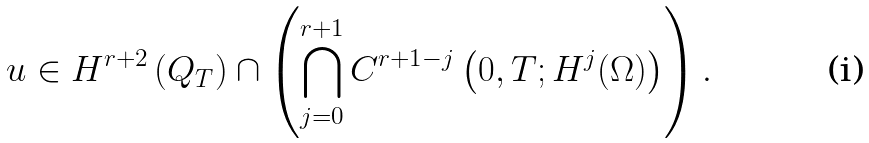<formula> <loc_0><loc_0><loc_500><loc_500>u \in H ^ { r + 2 } \left ( Q _ { T } \right ) \cap \left ( \bigcap _ { j = 0 } ^ { r + 1 } C ^ { r + 1 - j } \left ( 0 , T ; H ^ { j } ( \Omega ) \right ) \right ) .</formula> 